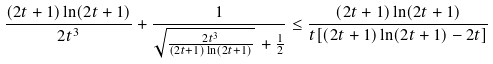Convert formula to latex. <formula><loc_0><loc_0><loc_500><loc_500>\frac { ( 2 t + 1 ) \ln ( 2 t + 1 ) } { 2 t ^ { 3 } } + \frac { 1 } { \sqrt { \frac { 2 t ^ { 3 } } { ( 2 t + 1 ) \ln ( 2 t + 1 ) } } \, + \frac { 1 } { 2 } } \leq \frac { ( 2 t + 1 ) \ln ( 2 t + 1 ) } { t [ ( 2 t + 1 ) \ln ( 2 t + 1 ) - 2 t ] }</formula> 